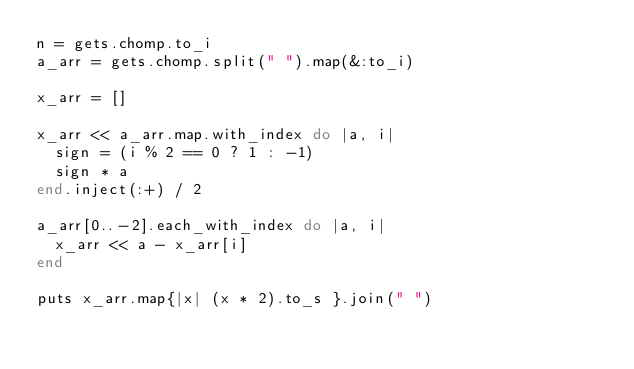<code> <loc_0><loc_0><loc_500><loc_500><_Ruby_>n = gets.chomp.to_i
a_arr = gets.chomp.split(" ").map(&:to_i)

x_arr = []

x_arr << a_arr.map.with_index do |a, i|
  sign = (i % 2 == 0 ? 1 : -1)
  sign * a
end.inject(:+) / 2

a_arr[0..-2].each_with_index do |a, i|
  x_arr << a - x_arr[i]
end

puts x_arr.map{|x| (x * 2).to_s }.join(" ")
</code> 